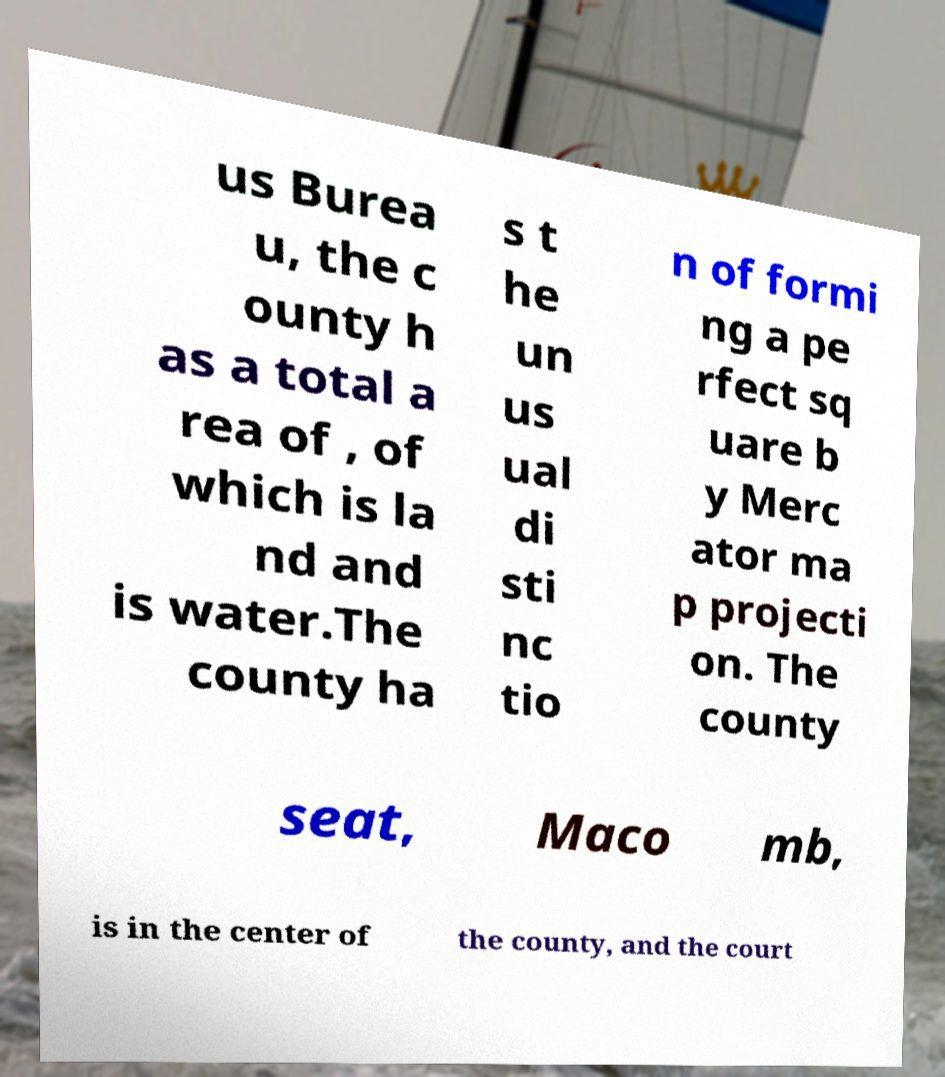Could you assist in decoding the text presented in this image and type it out clearly? us Burea u, the c ounty h as a total a rea of , of which is la nd and is water.The county ha s t he un us ual di sti nc tio n of formi ng a pe rfect sq uare b y Merc ator ma p projecti on. The county seat, Maco mb, is in the center of the county, and the court 